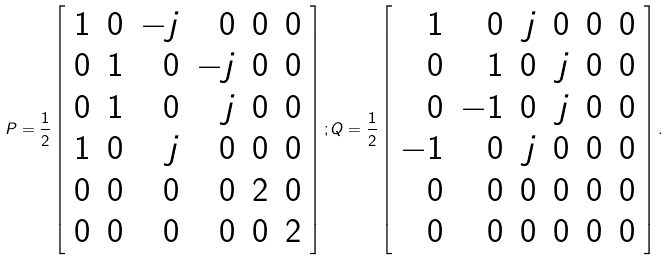Convert formula to latex. <formula><loc_0><loc_0><loc_500><loc_500>P = \frac { 1 } { 2 } \left [ \begin{array} { r r r r r r } 1 & 0 & - j & 0 & 0 & 0 \\ 0 & 1 & 0 & - j & 0 & 0 \\ 0 & 1 & 0 & j & 0 & 0 \\ 1 & 0 & j & 0 & 0 & 0 \\ 0 & 0 & 0 & 0 & 2 & 0 \\ 0 & 0 & 0 & 0 & 0 & 2 \\ \end{array} \right ] ; Q = \frac { 1 } { 2 } \left [ \begin{array} { r r r r r r } 1 & 0 & j & 0 & 0 & 0 \\ 0 & 1 & 0 & j & 0 & 0 \\ 0 & - 1 & 0 & j & 0 & 0 \\ - 1 & 0 & j & 0 & 0 & 0 \\ 0 & 0 & 0 & 0 & 0 & 0 \\ 0 & 0 & 0 & 0 & 0 & 0 \\ \end{array} \right ] .</formula> 